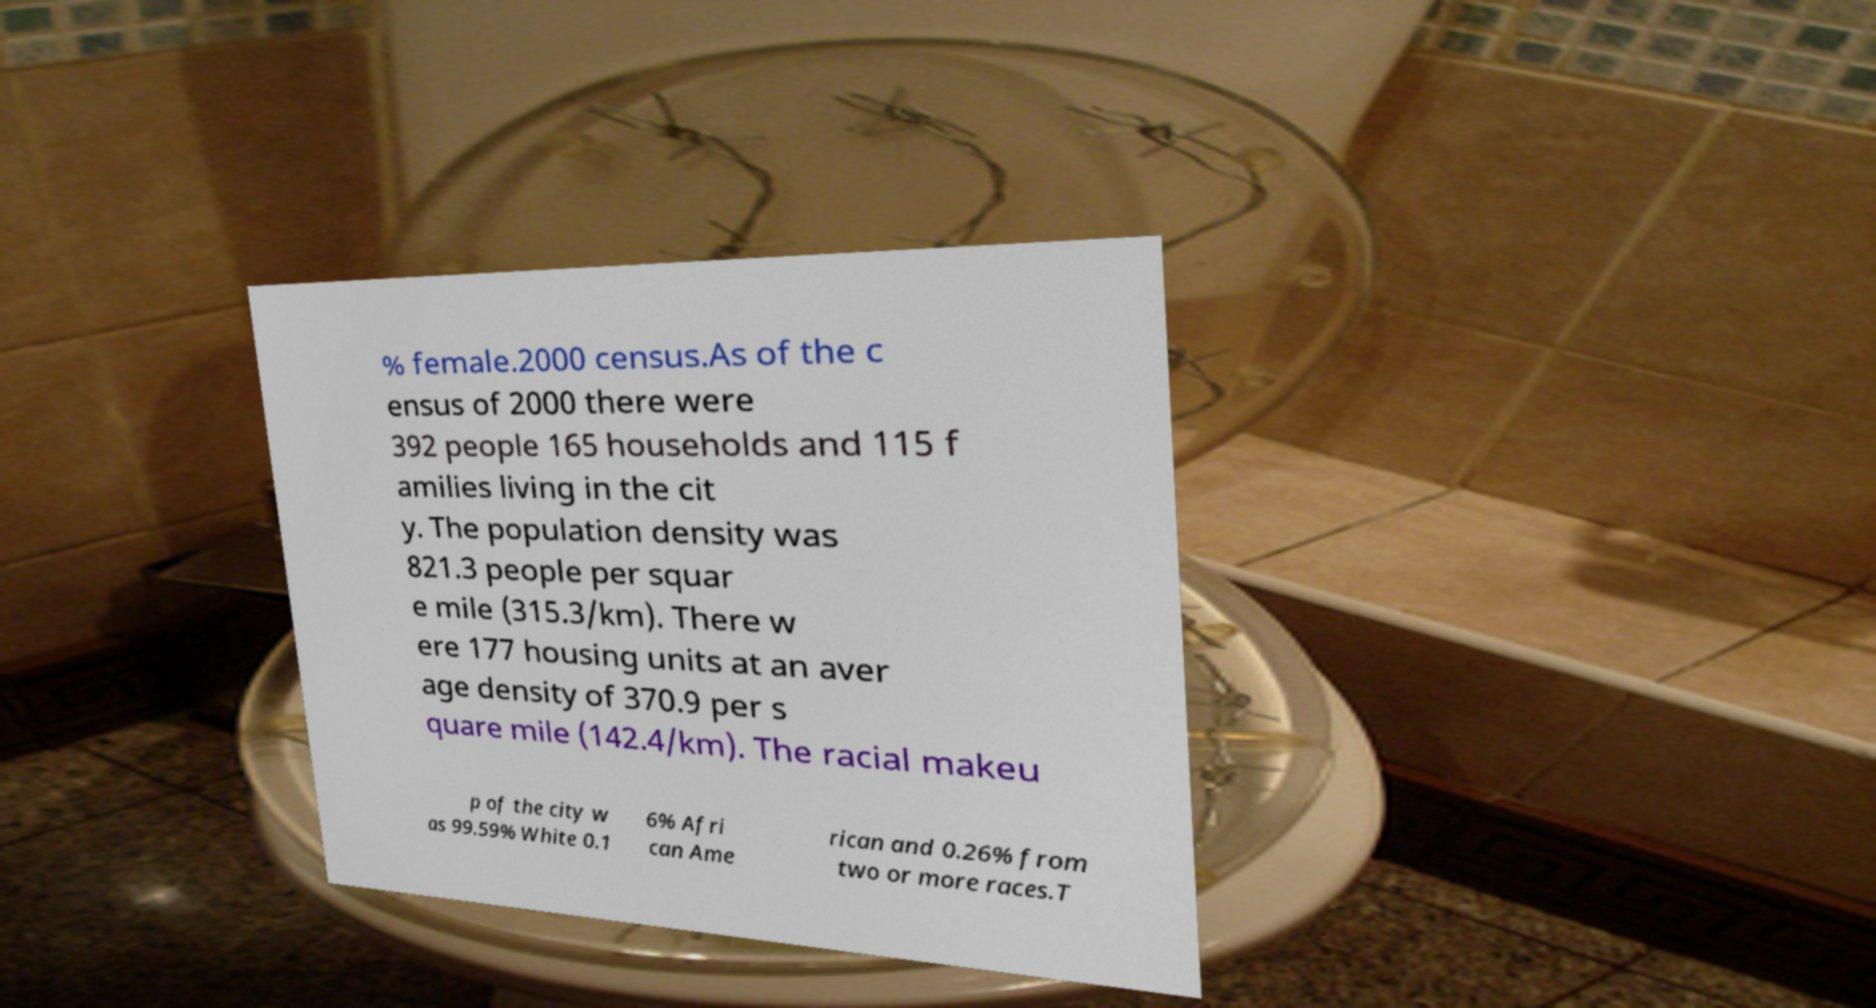Can you read and provide the text displayed in the image?This photo seems to have some interesting text. Can you extract and type it out for me? % female.2000 census.As of the c ensus of 2000 there were 392 people 165 households and 115 f amilies living in the cit y. The population density was 821.3 people per squar e mile (315.3/km). There w ere 177 housing units at an aver age density of 370.9 per s quare mile (142.4/km). The racial makeu p of the city w as 99.59% White 0.1 6% Afri can Ame rican and 0.26% from two or more races.T 